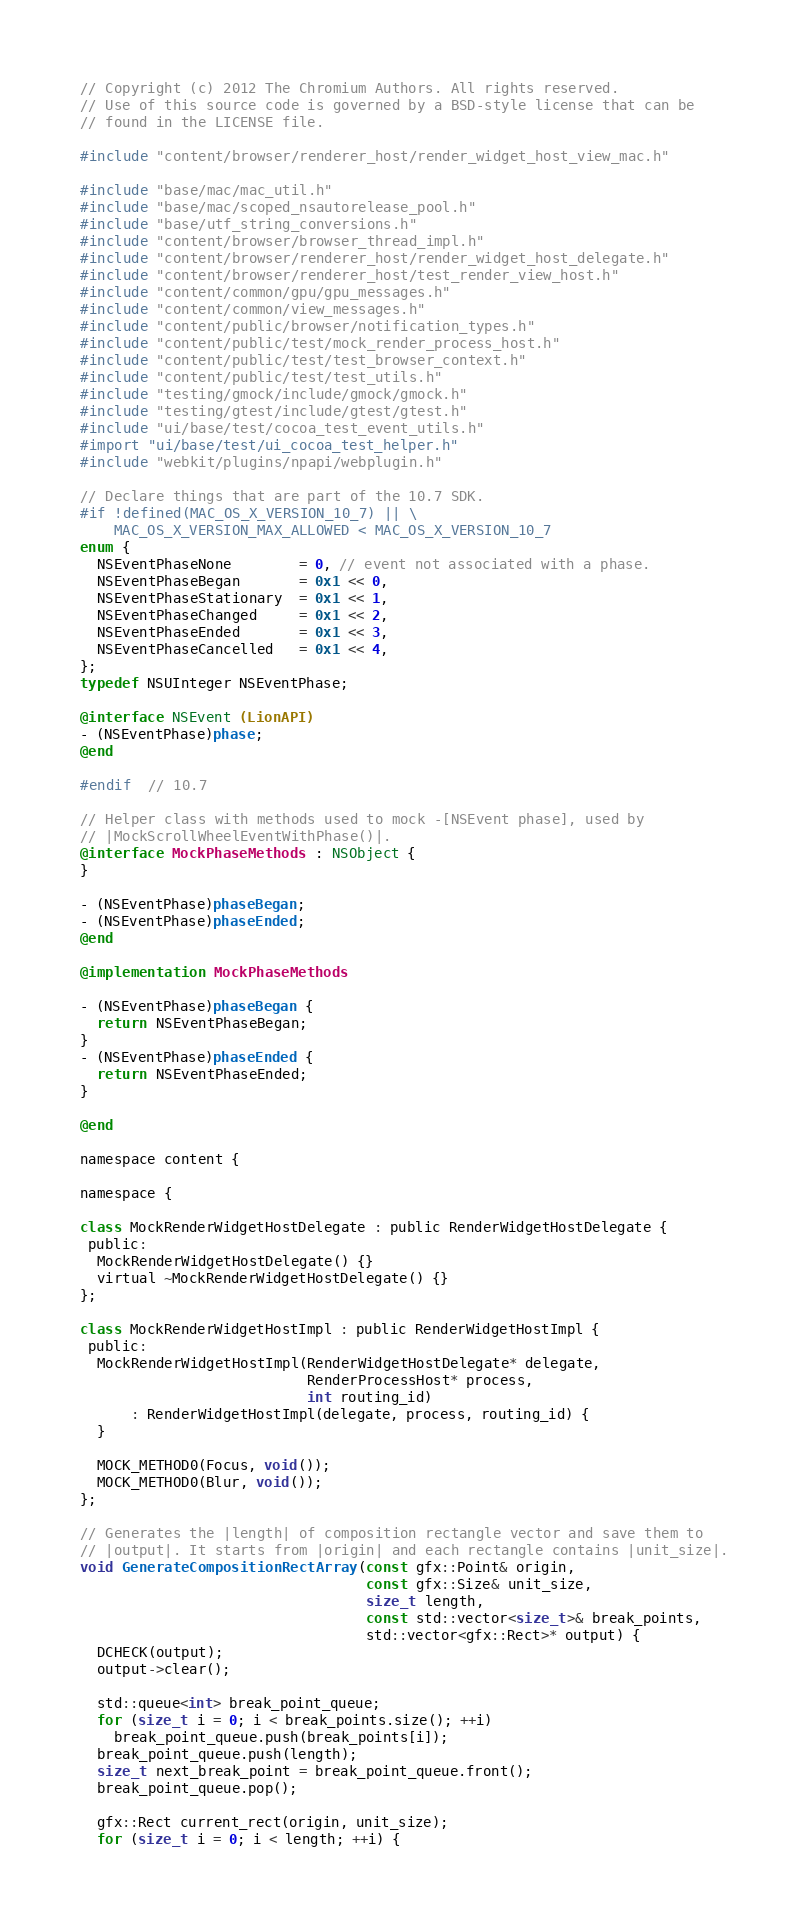Convert code to text. <code><loc_0><loc_0><loc_500><loc_500><_ObjectiveC_>// Copyright (c) 2012 The Chromium Authors. All rights reserved.
// Use of this source code is governed by a BSD-style license that can be
// found in the LICENSE file.

#include "content/browser/renderer_host/render_widget_host_view_mac.h"

#include "base/mac/mac_util.h"
#include "base/mac/scoped_nsautorelease_pool.h"
#include "base/utf_string_conversions.h"
#include "content/browser/browser_thread_impl.h"
#include "content/browser/renderer_host/render_widget_host_delegate.h"
#include "content/browser/renderer_host/test_render_view_host.h"
#include "content/common/gpu/gpu_messages.h"
#include "content/common/view_messages.h"
#include "content/public/browser/notification_types.h"
#include "content/public/test/mock_render_process_host.h"
#include "content/public/test/test_browser_context.h"
#include "content/public/test/test_utils.h"
#include "testing/gmock/include/gmock/gmock.h"
#include "testing/gtest/include/gtest/gtest.h"
#include "ui/base/test/cocoa_test_event_utils.h"
#import "ui/base/test/ui_cocoa_test_helper.h"
#include "webkit/plugins/npapi/webplugin.h"

// Declare things that are part of the 10.7 SDK.
#if !defined(MAC_OS_X_VERSION_10_7) || \
    MAC_OS_X_VERSION_MAX_ALLOWED < MAC_OS_X_VERSION_10_7
enum {
  NSEventPhaseNone        = 0, // event not associated with a phase.
  NSEventPhaseBegan       = 0x1 << 0,
  NSEventPhaseStationary  = 0x1 << 1,
  NSEventPhaseChanged     = 0x1 << 2,
  NSEventPhaseEnded       = 0x1 << 3,
  NSEventPhaseCancelled   = 0x1 << 4,
};
typedef NSUInteger NSEventPhase;

@interface NSEvent (LionAPI)
- (NSEventPhase)phase;
@end

#endif  // 10.7

// Helper class with methods used to mock -[NSEvent phase], used by
// |MockScrollWheelEventWithPhase()|.
@interface MockPhaseMethods : NSObject {
}

- (NSEventPhase)phaseBegan;
- (NSEventPhase)phaseEnded;
@end

@implementation MockPhaseMethods

- (NSEventPhase)phaseBegan {
  return NSEventPhaseBegan;
}
- (NSEventPhase)phaseEnded {
  return NSEventPhaseEnded;
}

@end

namespace content {

namespace {

class MockRenderWidgetHostDelegate : public RenderWidgetHostDelegate {
 public:
  MockRenderWidgetHostDelegate() {}
  virtual ~MockRenderWidgetHostDelegate() {}
};

class MockRenderWidgetHostImpl : public RenderWidgetHostImpl {
 public:
  MockRenderWidgetHostImpl(RenderWidgetHostDelegate* delegate,
                           RenderProcessHost* process,
                           int routing_id)
      : RenderWidgetHostImpl(delegate, process, routing_id) {
  }

  MOCK_METHOD0(Focus, void());
  MOCK_METHOD0(Blur, void());
};

// Generates the |length| of composition rectangle vector and save them to
// |output|. It starts from |origin| and each rectangle contains |unit_size|.
void GenerateCompositionRectArray(const gfx::Point& origin,
                                  const gfx::Size& unit_size,
                                  size_t length,
                                  const std::vector<size_t>& break_points,
                                  std::vector<gfx::Rect>* output) {
  DCHECK(output);
  output->clear();

  std::queue<int> break_point_queue;
  for (size_t i = 0; i < break_points.size(); ++i)
    break_point_queue.push(break_points[i]);
  break_point_queue.push(length);
  size_t next_break_point = break_point_queue.front();
  break_point_queue.pop();

  gfx::Rect current_rect(origin, unit_size);
  for (size_t i = 0; i < length; ++i) {</code> 